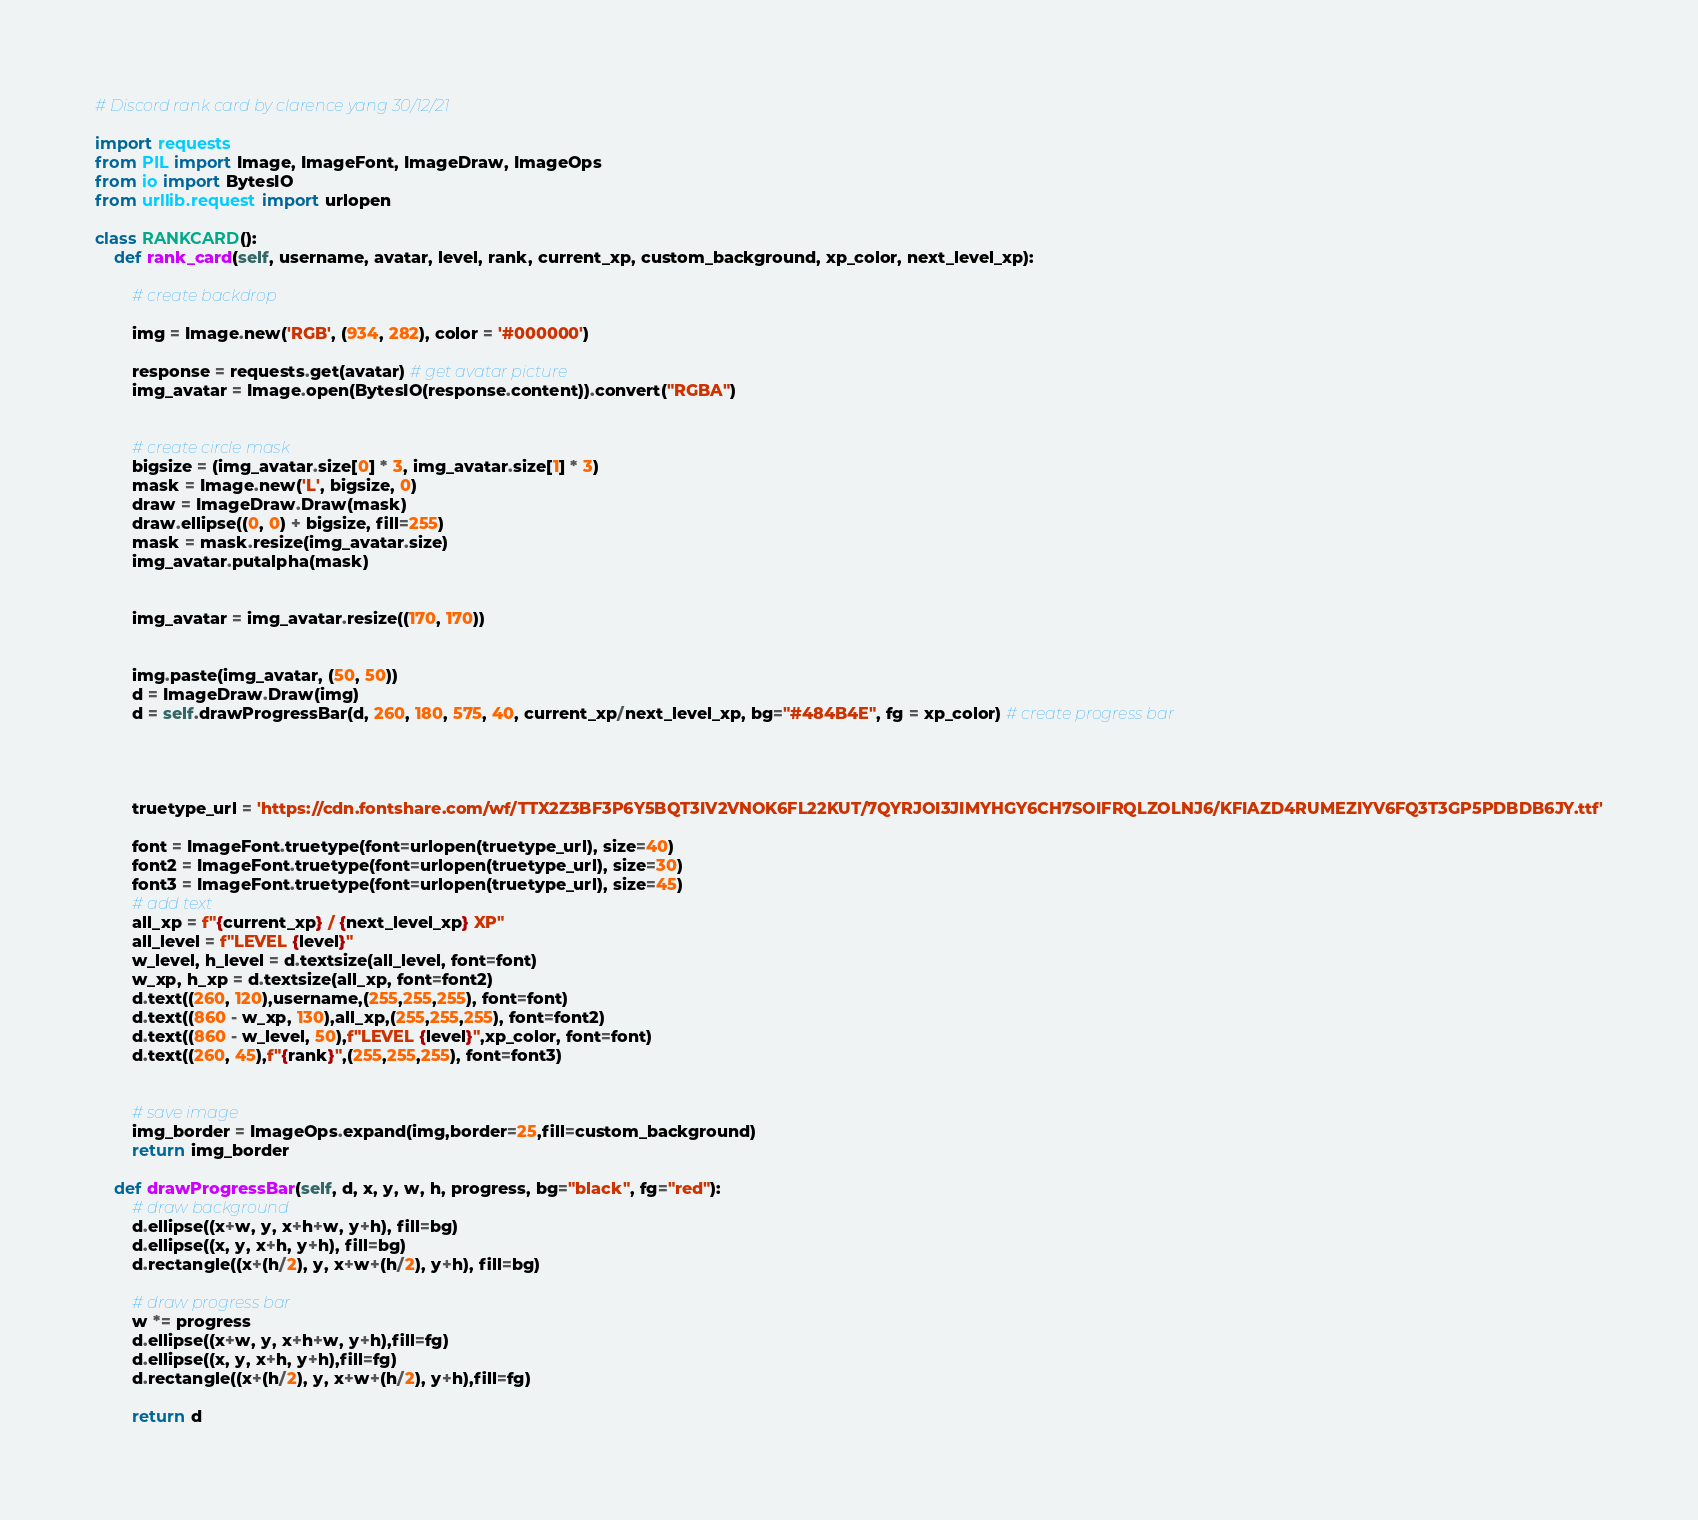Convert code to text. <code><loc_0><loc_0><loc_500><loc_500><_Python_># Discord rank card by clarence yang 30/12/21

import requests
from PIL import Image, ImageFont, ImageDraw, ImageOps
from io import BytesIO
from urllib.request import urlopen

class RANKCARD():
    def rank_card(self, username, avatar, level, rank, current_xp, custom_background, xp_color, next_level_xp):

        # create backdrop

        img = Image.new('RGB', (934, 282), color = '#000000')
  
        response = requests.get(avatar) # get avatar picture
        img_avatar = Image.open(BytesIO(response.content)).convert("RGBA")
        

        # create circle mask
        bigsize = (img_avatar.size[0] * 3, img_avatar.size[1] * 3)
        mask = Image.new('L', bigsize, 0)
        draw = ImageDraw.Draw(mask) 
        draw.ellipse((0, 0) + bigsize, fill=255)
        mask = mask.resize(img_avatar.size)
        img_avatar.putalpha(mask)


        img_avatar = img_avatar.resize((170, 170))
        

        img.paste(img_avatar, (50, 50))
        d = ImageDraw.Draw(img)
        d = self.drawProgressBar(d, 260, 180, 575, 40, current_xp/next_level_xp, bg="#484B4E", fg = xp_color) # create progress bar
       


        
        truetype_url = 'https://cdn.fontshare.com/wf/TTX2Z3BF3P6Y5BQT3IV2VNOK6FL22KUT/7QYRJOI3JIMYHGY6CH7SOIFRQLZOLNJ6/KFIAZD4RUMEZIYV6FQ3T3GP5PDBDB6JY.ttf'

        font = ImageFont.truetype(font=urlopen(truetype_url), size=40)
        font2 = ImageFont.truetype(font=urlopen(truetype_url), size=30)
        font3 = ImageFont.truetype(font=urlopen(truetype_url), size=45)
        # add text
        all_xp = f"{current_xp} / {next_level_xp} XP"
        all_level = f"LEVEL {level}"
        w_level, h_level = d.textsize(all_level, font=font)
        w_xp, h_xp = d.textsize(all_xp, font=font2)
        d.text((260, 120),username,(255,255,255), font=font)
        d.text((860 - w_xp, 130),all_xp,(255,255,255), font=font2)
        d.text((860 - w_level, 50),f"LEVEL {level}",xp_color, font=font)
        d.text((260, 45),f"{rank}",(255,255,255), font=font3)


        # save image
        img_border = ImageOps.expand(img,border=25,fill=custom_background)
        return img_border
    
    def drawProgressBar(self, d, x, y, w, h, progress, bg="black", fg="red"):
        # draw background
        d.ellipse((x+w, y, x+h+w, y+h), fill=bg)
        d.ellipse((x, y, x+h, y+h), fill=bg)
        d.rectangle((x+(h/2), y, x+w+(h/2), y+h), fill=bg)

        # draw progress bar
        w *= progress
        d.ellipse((x+w, y, x+h+w, y+h),fill=fg)
        d.ellipse((x, y, x+h, y+h),fill=fg)
        d.rectangle((x+(h/2), y, x+w+(h/2), y+h),fill=fg)

        return d


</code> 